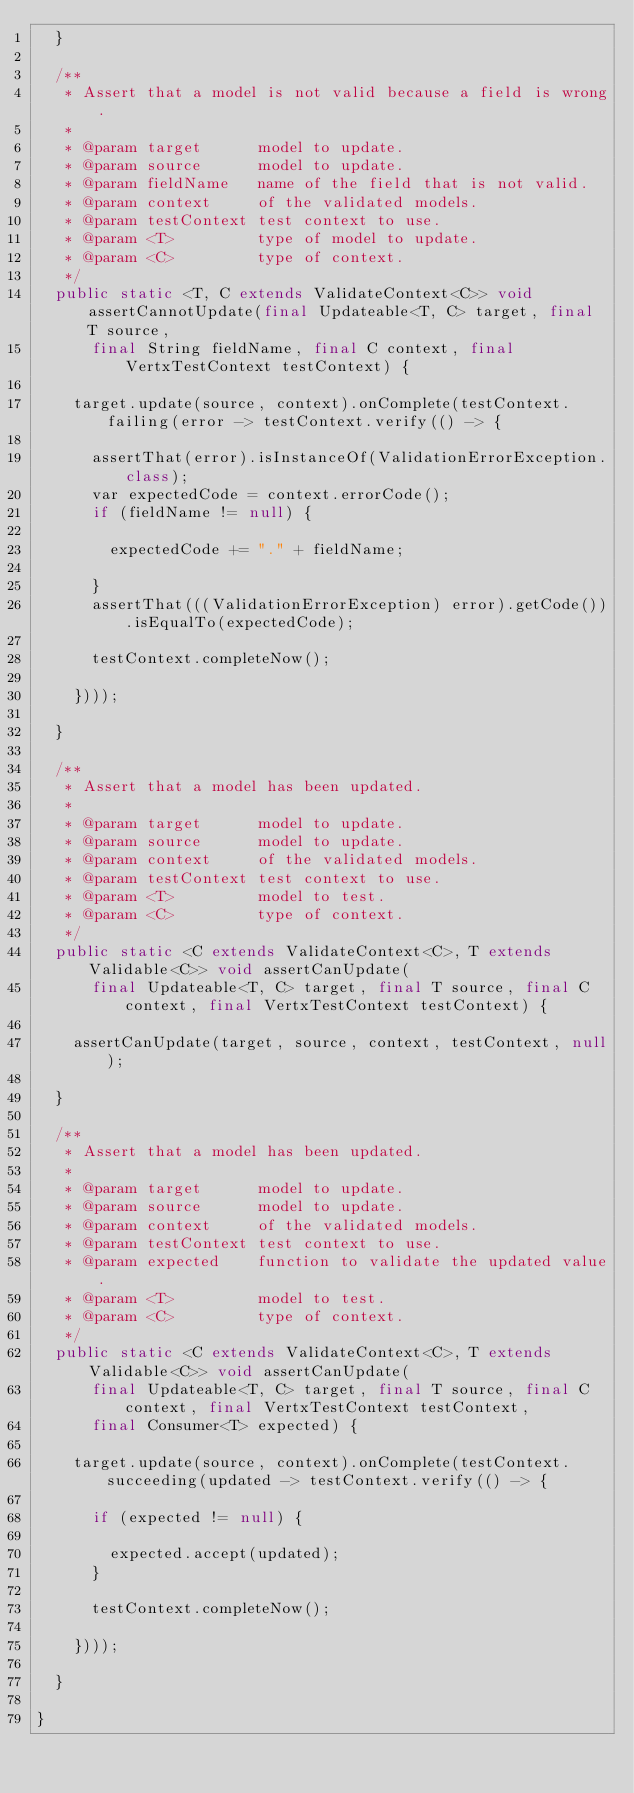Convert code to text. <code><loc_0><loc_0><loc_500><loc_500><_Java_>  }

  /**
   * Assert that a model is not valid because a field is wrong.
   *
   * @param target      model to update.
   * @param source      model to update.
   * @param fieldName   name of the field that is not valid.
   * @param context     of the validated models.
   * @param testContext test context to use.
   * @param <T>         type of model to update.
   * @param <C>         type of context.
   */
  public static <T, C extends ValidateContext<C>> void assertCannotUpdate(final Updateable<T, C> target, final T source,
      final String fieldName, final C context, final VertxTestContext testContext) {

    target.update(source, context).onComplete(testContext.failing(error -> testContext.verify(() -> {

      assertThat(error).isInstanceOf(ValidationErrorException.class);
      var expectedCode = context.errorCode();
      if (fieldName != null) {

        expectedCode += "." + fieldName;

      }
      assertThat(((ValidationErrorException) error).getCode()).isEqualTo(expectedCode);

      testContext.completeNow();

    })));

  }

  /**
   * Assert that a model has been updated.
   *
   * @param target      model to update.
   * @param source      model to update.
   * @param context     of the validated models.
   * @param testContext test context to use.
   * @param <T>         model to test.
   * @param <C>         type of context.
   */
  public static <C extends ValidateContext<C>, T extends Validable<C>> void assertCanUpdate(
      final Updateable<T, C> target, final T source, final C context, final VertxTestContext testContext) {

    assertCanUpdate(target, source, context, testContext, null);

  }

  /**
   * Assert that a model has been updated.
   *
   * @param target      model to update.
   * @param source      model to update.
   * @param context     of the validated models.
   * @param testContext test context to use.
   * @param expected    function to validate the updated value.
   * @param <T>         model to test.
   * @param <C>         type of context.
   */
  public static <C extends ValidateContext<C>, T extends Validable<C>> void assertCanUpdate(
      final Updateable<T, C> target, final T source, final C context, final VertxTestContext testContext,
      final Consumer<T> expected) {

    target.update(source, context).onComplete(testContext.succeeding(updated -> testContext.verify(() -> {

      if (expected != null) {

        expected.accept(updated);
      }

      testContext.completeNow();

    })));

  }

}
</code> 